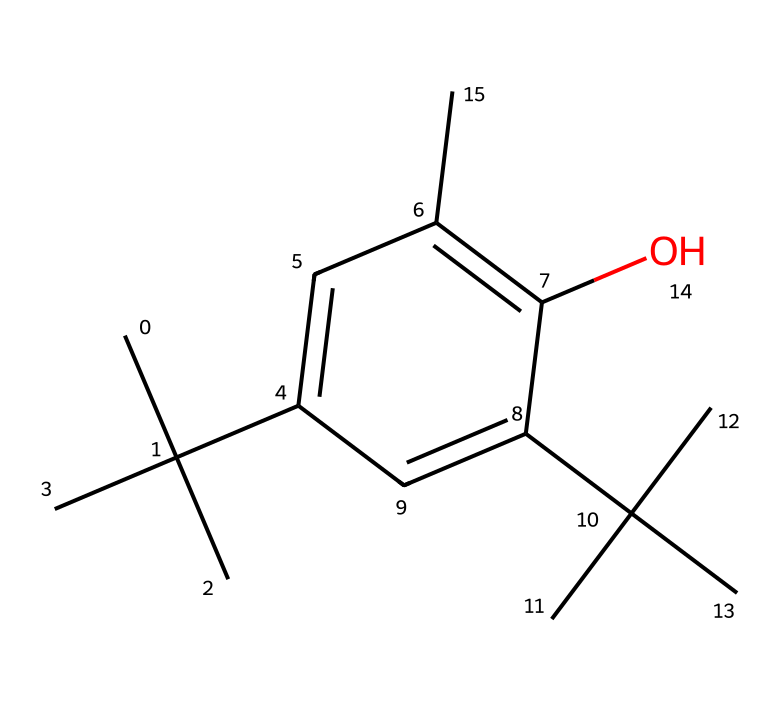How many carbon atoms are present in this molecule? By analyzing the SMILES representation, we observe several "C" characters representing carbon atoms, leading to the conclusion that there are 15 carbon atoms in total.
Answer: 15 What type of functional group is present in this chemical? The presence of the “-OH” group indicates that this chemical contains a hydroxyl functional group, classifying it as an alcohol derivative.
Answer: hydroxyl What is the molecular formula of butylated hydroxytoluene (BHT)? By counting the atoms from the SMILES, we derive the molecular formula to be C15H24O, indicating the composition of the molecule in terms of carbon, hydrogen, and oxygen.
Answer: C15H24O Does this compound contain any rings in its structure? The structure contains a benzene ring, which is indicated by the notation "C1" and "C=CC" in the SMILES, signifying cyclic arrangements of carbon atoms.
Answer: yes How many hydroxyl groups are present in this structure? The presence of a single "O" in the SMILES along with the adjacent "C" confirms there is only one hydroxyl group in this molecule.
Answer: 1 Is butylated hydroxytoluene a primary or secondary antioxidant? BHT acts as a secondary antioxidant because it helps to regenerate primary antioxidants and reduces oxidative damage by neutralizing free radicals.
Answer: secondary 